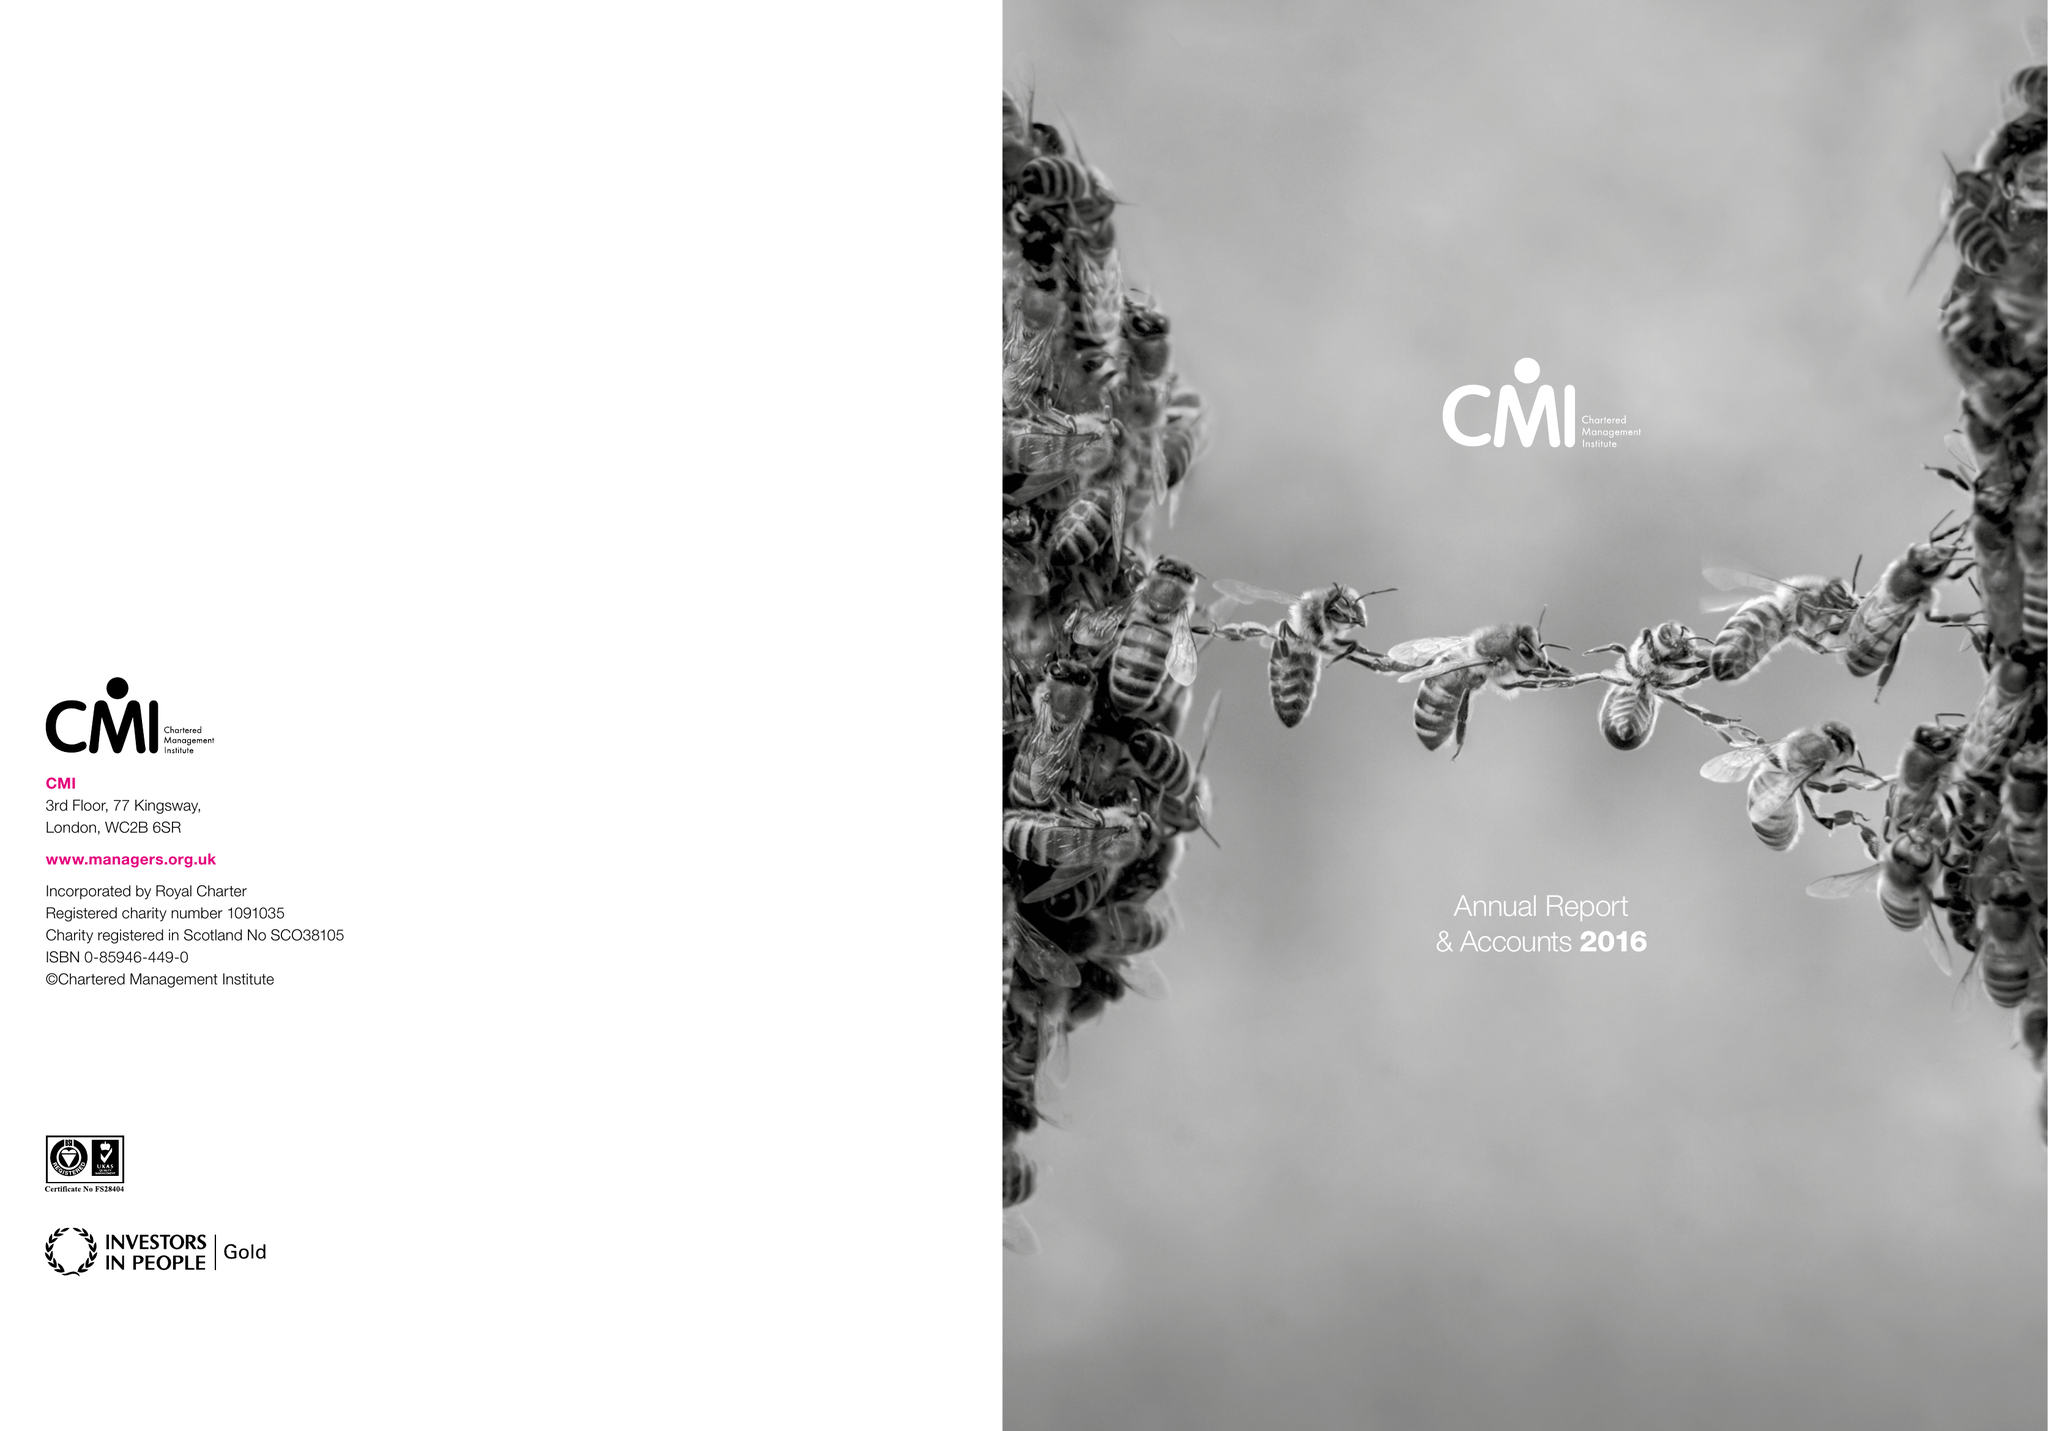What is the value for the charity_number?
Answer the question using a single word or phrase. 1091035 